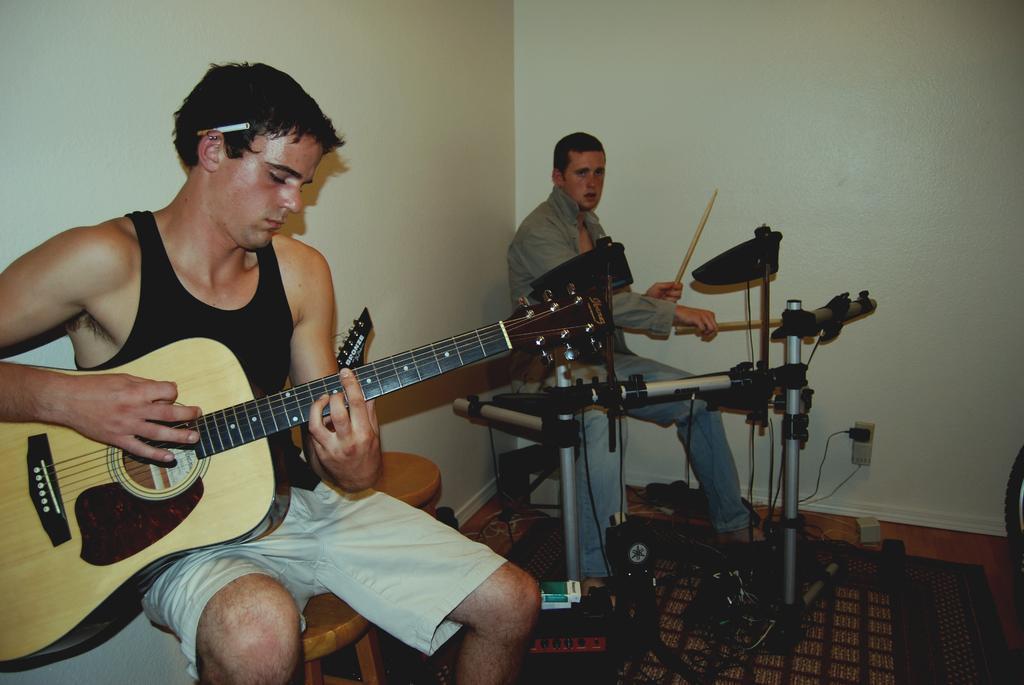How would you summarize this image in a sentence or two? In this image, In the left side there is a boy siting and he is holding a music instrument, In the middle there is a man siting and he is playing some music instruments, In the background there is a white color wall. 